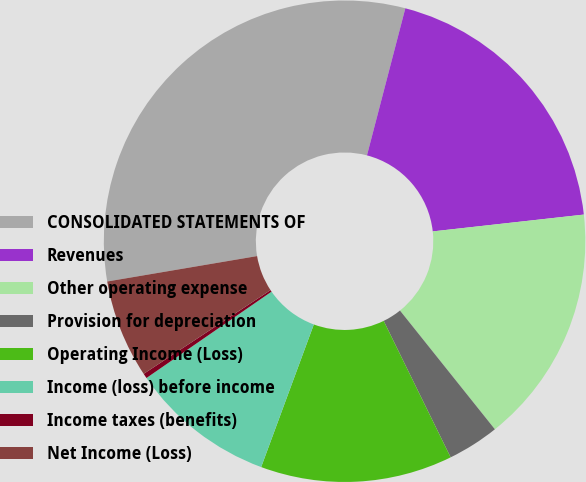Convert chart to OTSL. <chart><loc_0><loc_0><loc_500><loc_500><pie_chart><fcel>CONSOLIDATED STATEMENTS OF<fcel>Revenues<fcel>Other operating expense<fcel>Provision for depreciation<fcel>Operating Income (Loss)<fcel>Income (loss) before income<fcel>Income taxes (benefits)<fcel>Net Income (Loss)<nl><fcel>31.73%<fcel>19.17%<fcel>16.03%<fcel>3.47%<fcel>12.89%<fcel>9.75%<fcel>0.33%<fcel>6.61%<nl></chart> 